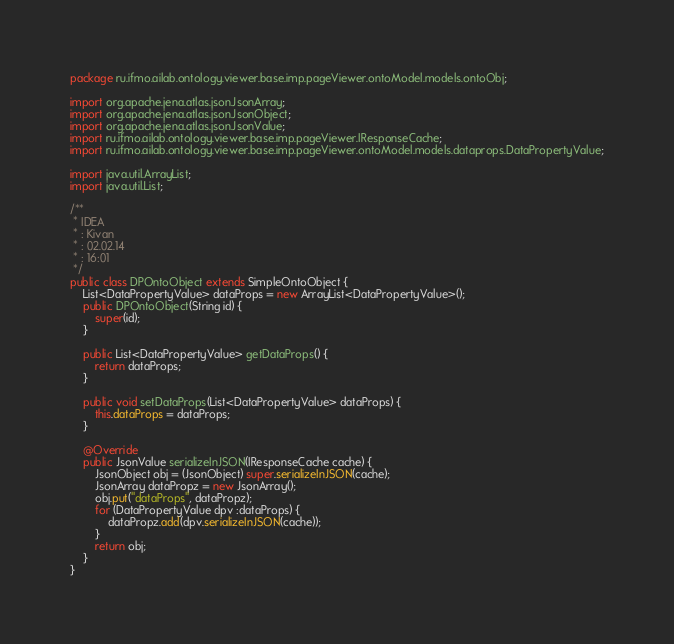<code> <loc_0><loc_0><loc_500><loc_500><_Java_>package ru.ifmo.ailab.ontology.viewer.base.imp.pageViewer.ontoModel.models.ontoObj;

import org.apache.jena.atlas.json.JsonArray;
import org.apache.jena.atlas.json.JsonObject;
import org.apache.jena.atlas.json.JsonValue;
import ru.ifmo.ailab.ontology.viewer.base.imp.pageViewer.IResponseCache;
import ru.ifmo.ailab.ontology.viewer.base.imp.pageViewer.ontoModel.models.dataprops.DataPropertyValue;

import java.util.ArrayList;
import java.util.List;

/**
 * IDEA
 * : Kivan
 * : 02.02.14
 * : 16:01
 */
public class DPOntoObject extends SimpleOntoObject {
    List<DataPropertyValue> dataProps = new ArrayList<DataPropertyValue>();
    public DPOntoObject(String id) {
        super(id);
    }

    public List<DataPropertyValue> getDataProps() {
        return dataProps;
    }

    public void setDataProps(List<DataPropertyValue> dataProps) {
        this.dataProps = dataProps;
    }

    @Override
    public JsonValue serializeInJSON(IResponseCache cache) {
        JsonObject obj = (JsonObject) super.serializeInJSON(cache);
        JsonArray dataPropz = new JsonArray();
        obj.put("dataProps", dataPropz);
        for (DataPropertyValue dpv :dataProps) {
            dataPropz.add(dpv.serializeInJSON(cache));
        }
        return obj;
    }
}
</code> 